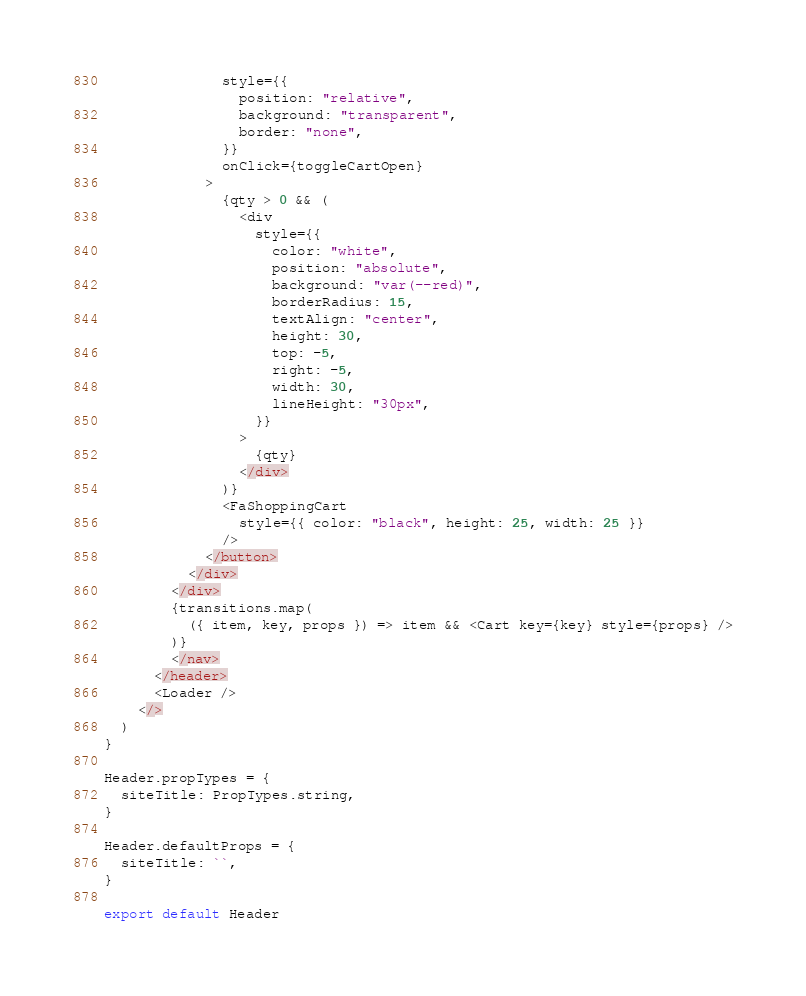Convert code to text. <code><loc_0><loc_0><loc_500><loc_500><_JavaScript_>              style={{
                position: "relative",
                background: "transparent",
                border: "none",
              }}
              onClick={toggleCartOpen}
            >
              {qty > 0 && (
                <div
                  style={{
                    color: "white",
                    position: "absolute",
                    background: "var(--red)",
                    borderRadius: 15,
                    textAlign: "center",
                    height: 30,
                    top: -5,
                    right: -5,
                    width: 30,
                    lineHeight: "30px",
                  }}
                >
                  {qty}
                </div>
              )}
              <FaShoppingCart
                style={{ color: "black", height: 25, width: 25 }}
              />
            </button>
          </div>
        </div>
        {transitions.map(
          ({ item, key, props }) => item && <Cart key={key} style={props} />
        )}
        </nav>
      </header>
      <Loader />
    </>
  )
}

Header.propTypes = {
  siteTitle: PropTypes.string,
}

Header.defaultProps = {
  siteTitle: ``,
}

export default Header
</code> 